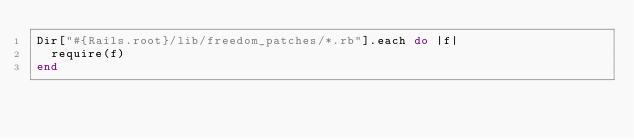Convert code to text. <code><loc_0><loc_0><loc_500><loc_500><_Ruby_>Dir["#{Rails.root}/lib/freedom_patches/*.rb"].each do |f|
  require(f)
end
</code> 